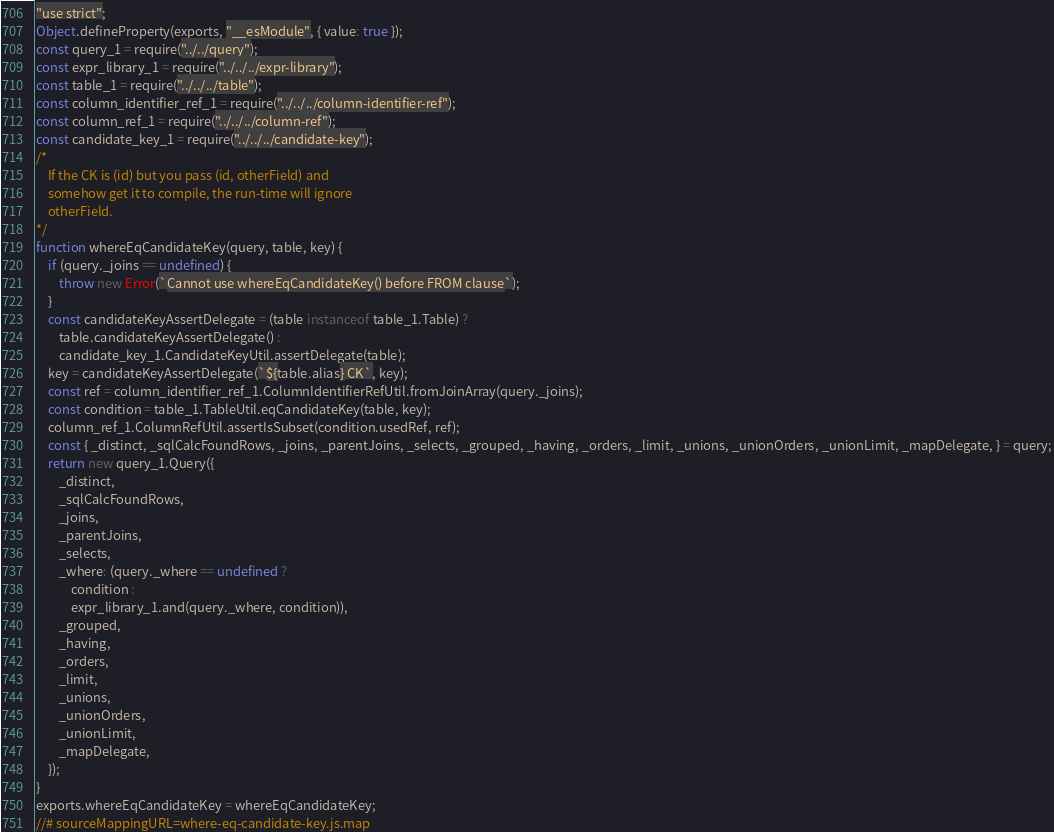Convert code to text. <code><loc_0><loc_0><loc_500><loc_500><_JavaScript_>"use strict";
Object.defineProperty(exports, "__esModule", { value: true });
const query_1 = require("../../query");
const expr_library_1 = require("../../../expr-library");
const table_1 = require("../../../table");
const column_identifier_ref_1 = require("../../../column-identifier-ref");
const column_ref_1 = require("../../../column-ref");
const candidate_key_1 = require("../../../candidate-key");
/*
    If the CK is (id) but you pass (id, otherField) and
    somehow get it to compile, the run-time will ignore
    otherField.
*/
function whereEqCandidateKey(query, table, key) {
    if (query._joins == undefined) {
        throw new Error(`Cannot use whereEqCandidateKey() before FROM clause`);
    }
    const candidateKeyAssertDelegate = (table instanceof table_1.Table) ?
        table.candidateKeyAssertDelegate() :
        candidate_key_1.CandidateKeyUtil.assertDelegate(table);
    key = candidateKeyAssertDelegate(`${table.alias} CK`, key);
    const ref = column_identifier_ref_1.ColumnIdentifierRefUtil.fromJoinArray(query._joins);
    const condition = table_1.TableUtil.eqCandidateKey(table, key);
    column_ref_1.ColumnRefUtil.assertIsSubset(condition.usedRef, ref);
    const { _distinct, _sqlCalcFoundRows, _joins, _parentJoins, _selects, _grouped, _having, _orders, _limit, _unions, _unionOrders, _unionLimit, _mapDelegate, } = query;
    return new query_1.Query({
        _distinct,
        _sqlCalcFoundRows,
        _joins,
        _parentJoins,
        _selects,
        _where: (query._where == undefined ?
            condition :
            expr_library_1.and(query._where, condition)),
        _grouped,
        _having,
        _orders,
        _limit,
        _unions,
        _unionOrders,
        _unionLimit,
        _mapDelegate,
    });
}
exports.whereEqCandidateKey = whereEqCandidateKey;
//# sourceMappingURL=where-eq-candidate-key.js.map</code> 